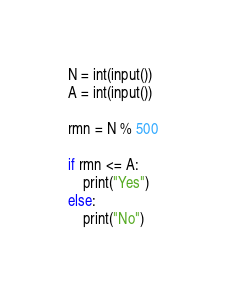<code> <loc_0><loc_0><loc_500><loc_500><_Python_>N = int(input())
A = int(input())

rmn = N % 500

if rmn <= A:
    print("Yes")
else:
    print("No")
</code> 